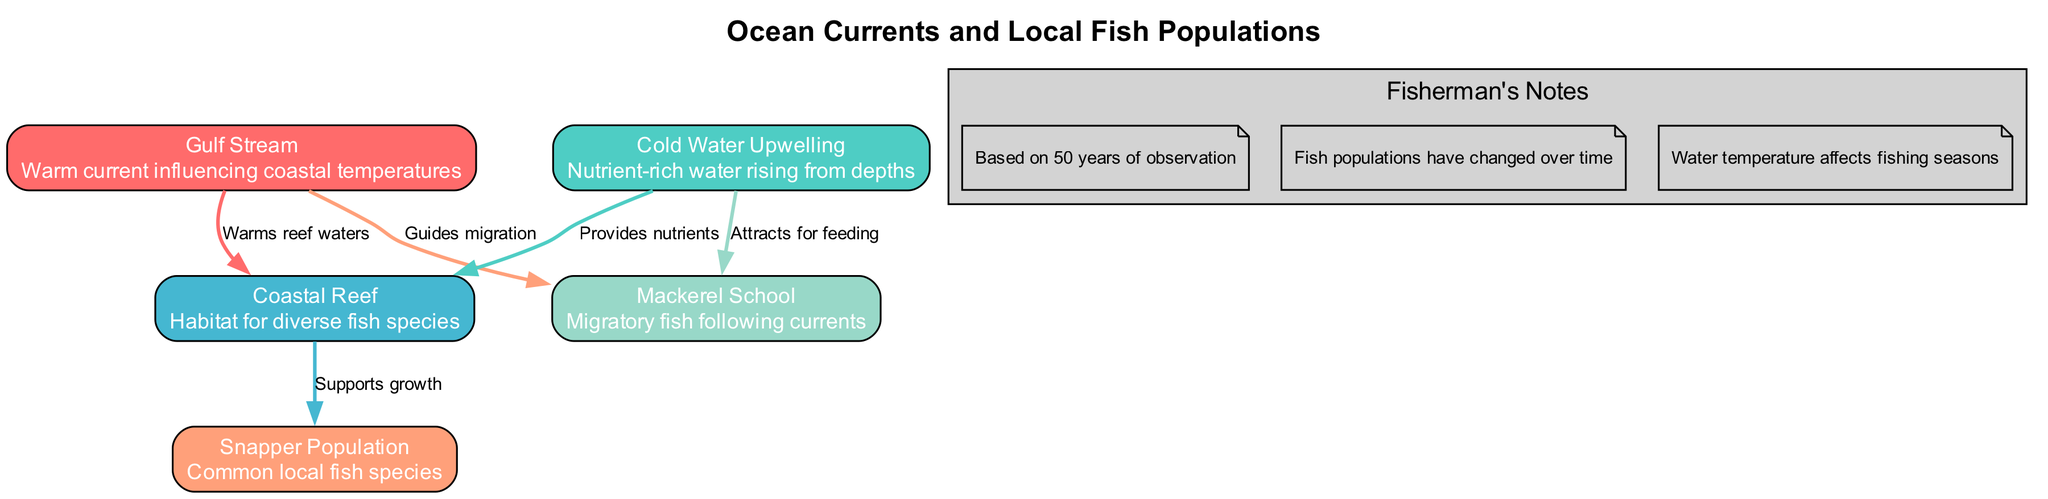What is the warm current influencing coastal temperatures? The diagram identifies the warm current as the "Gulf Stream," which is explicitly labeled among the nodes.
Answer: Gulf Stream How many nodes are present in the diagram? By counting the distinct nodes listed, there are a total of 5 nodes shown: Gulf Stream, Cold Water Upwelling, Coastal Reef, Snapper Population, and Mackerel School.
Answer: 5 What does the Cold Water Upwelling provide to the Coastal Reef? The relationship between the Cold Water Upwelling and Coastal Reef indicates that it "Provides nutrients," which is specified in the edge label connecting these two nodes.
Answer: Provides nutrients Which population is supported by the Coastal Reef? The diagram shows that the Coastal Reef supports the "Snapper Population," as indicated by the labeled edge connecting these two nodes.
Answer: Snapper Population How does the Gulf Stream influence the Mackerel School? The diagram states that the Gulf Stream "Guides migration" for the Mackerel School, which is the connection between these two nodes.
Answer: Guides migration What type of fish species is attracted to the Cold Water Upwelling? The diagram reveals that the Mackerel School is attracted to the Cold Water Upwelling for feeding, as labeled in the edge connecting these nodes.
Answer: Mackerel School What habitat is represented in the diagram? The diagram identifies the "Coastal Reef" as the habitat for diverse fish species, which is one of the nodes present.
Answer: Coastal Reef What impact does water temperature have on fishing seasons? The notes indicate that water temperature affects fishing seasons, suggesting that variations in temperature can determine the best times to fish.
Answer: Affects fishing seasons What is the common local fish species shown in the diagram? The diagram specifies the "Snapper Population" as a common local fish species, which is labeled among the nodes.
Answer: Snapper Population 